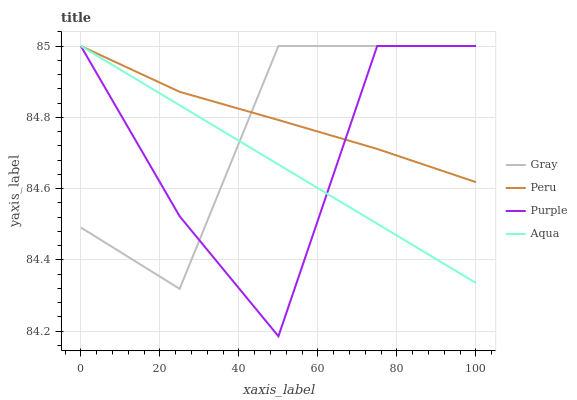Does Gray have the minimum area under the curve?
Answer yes or no. No. Does Gray have the maximum area under the curve?
Answer yes or no. No. Is Gray the smoothest?
Answer yes or no. No. Is Gray the roughest?
Answer yes or no. No. Does Gray have the lowest value?
Answer yes or no. No. 